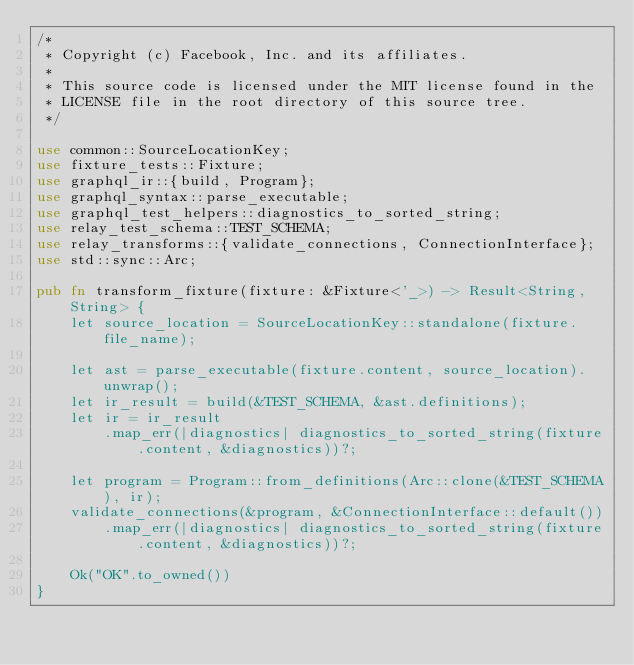<code> <loc_0><loc_0><loc_500><loc_500><_Rust_>/*
 * Copyright (c) Facebook, Inc. and its affiliates.
 *
 * This source code is licensed under the MIT license found in the
 * LICENSE file in the root directory of this source tree.
 */

use common::SourceLocationKey;
use fixture_tests::Fixture;
use graphql_ir::{build, Program};
use graphql_syntax::parse_executable;
use graphql_test_helpers::diagnostics_to_sorted_string;
use relay_test_schema::TEST_SCHEMA;
use relay_transforms::{validate_connections, ConnectionInterface};
use std::sync::Arc;

pub fn transform_fixture(fixture: &Fixture<'_>) -> Result<String, String> {
    let source_location = SourceLocationKey::standalone(fixture.file_name);

    let ast = parse_executable(fixture.content, source_location).unwrap();
    let ir_result = build(&TEST_SCHEMA, &ast.definitions);
    let ir = ir_result
        .map_err(|diagnostics| diagnostics_to_sorted_string(fixture.content, &diagnostics))?;

    let program = Program::from_definitions(Arc::clone(&TEST_SCHEMA), ir);
    validate_connections(&program, &ConnectionInterface::default())
        .map_err(|diagnostics| diagnostics_to_sorted_string(fixture.content, &diagnostics))?;

    Ok("OK".to_owned())
}
</code> 